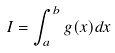<formula> <loc_0><loc_0><loc_500><loc_500>I = \int _ { a } ^ { b } g ( x ) d x</formula> 